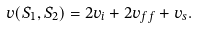<formula> <loc_0><loc_0><loc_500><loc_500>v ( S _ { 1 } , S _ { 2 } ) = 2 v _ { i } + 2 v _ { f f } + v _ { s } .</formula> 